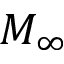Convert formula to latex. <formula><loc_0><loc_0><loc_500><loc_500>M _ { \infty }</formula> 